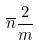<formula> <loc_0><loc_0><loc_500><loc_500>\overline { n } \frac { 2 } { m }</formula> 